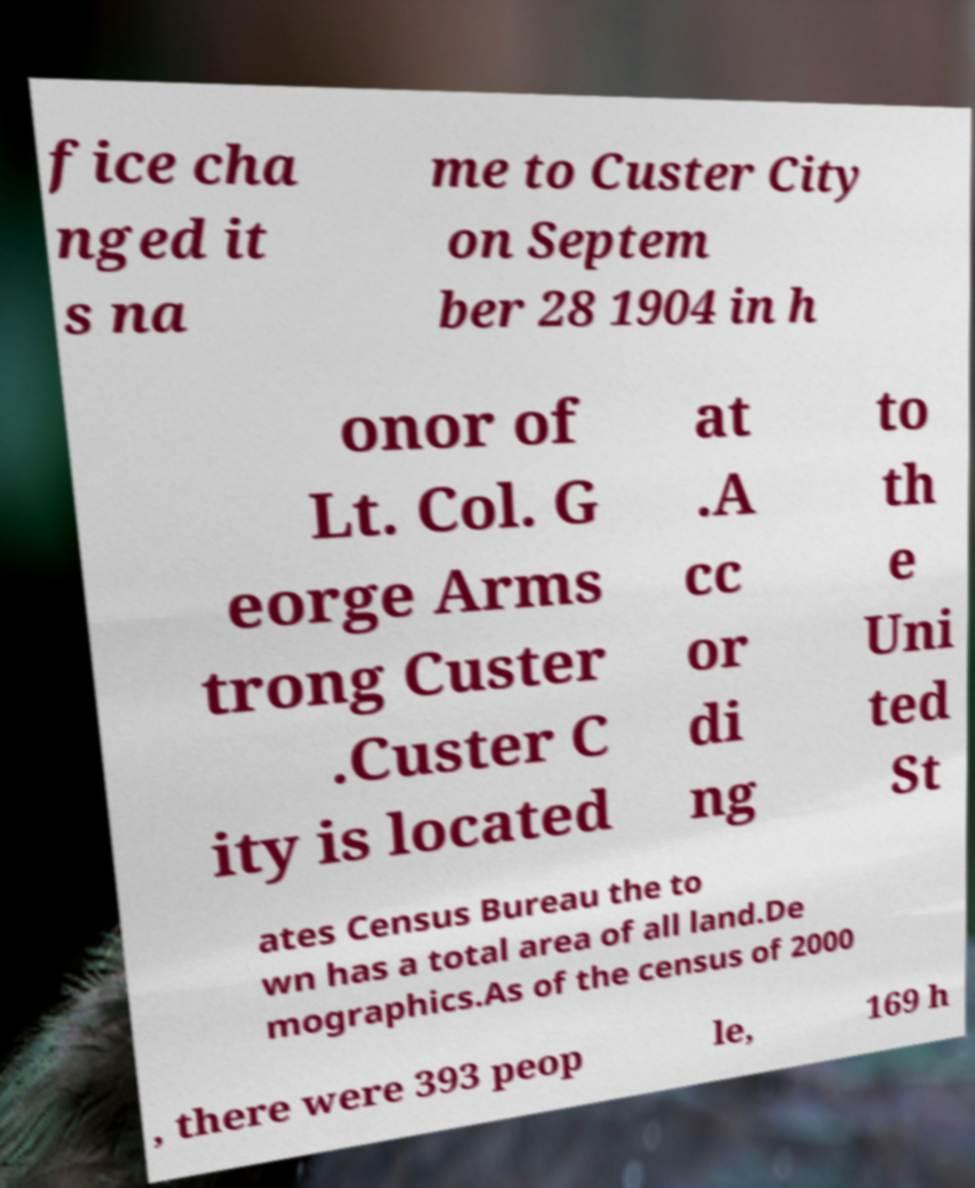Please identify and transcribe the text found in this image. fice cha nged it s na me to Custer City on Septem ber 28 1904 in h onor of Lt. Col. G eorge Arms trong Custer .Custer C ity is located at .A cc or di ng to th e Uni ted St ates Census Bureau the to wn has a total area of all land.De mographics.As of the census of 2000 , there were 393 peop le, 169 h 